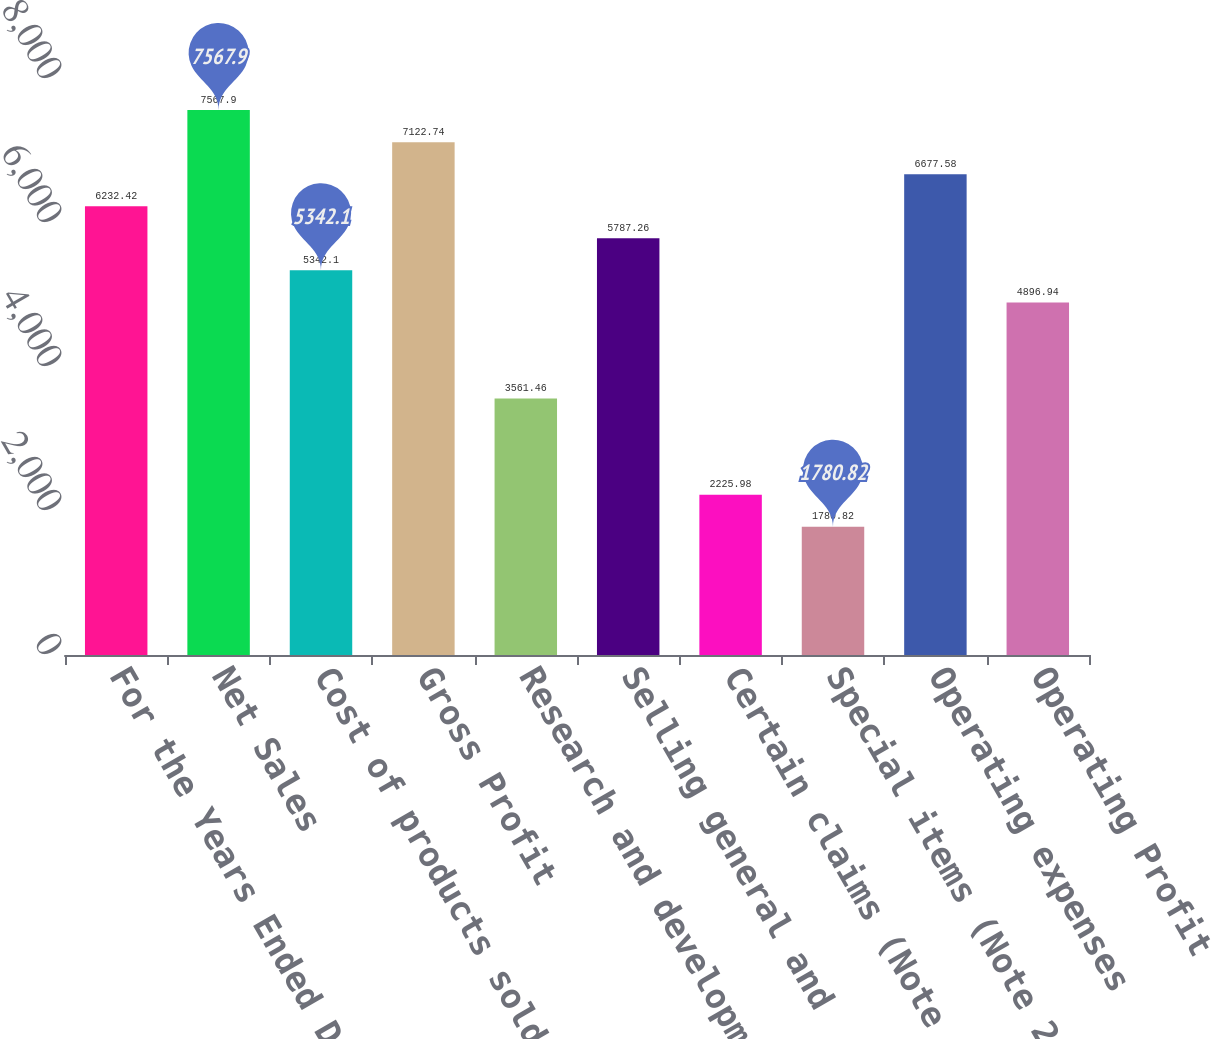Convert chart. <chart><loc_0><loc_0><loc_500><loc_500><bar_chart><fcel>For the Years Ended December<fcel>Net Sales<fcel>Cost of products sold<fcel>Gross Profit<fcel>Research and development<fcel>Selling general and<fcel>Certain claims (Note 19)<fcel>Special items (Note 2)<fcel>Operating expenses<fcel>Operating Profit<nl><fcel>6232.42<fcel>7567.9<fcel>5342.1<fcel>7122.74<fcel>3561.46<fcel>5787.26<fcel>2225.98<fcel>1780.82<fcel>6677.58<fcel>4896.94<nl></chart> 